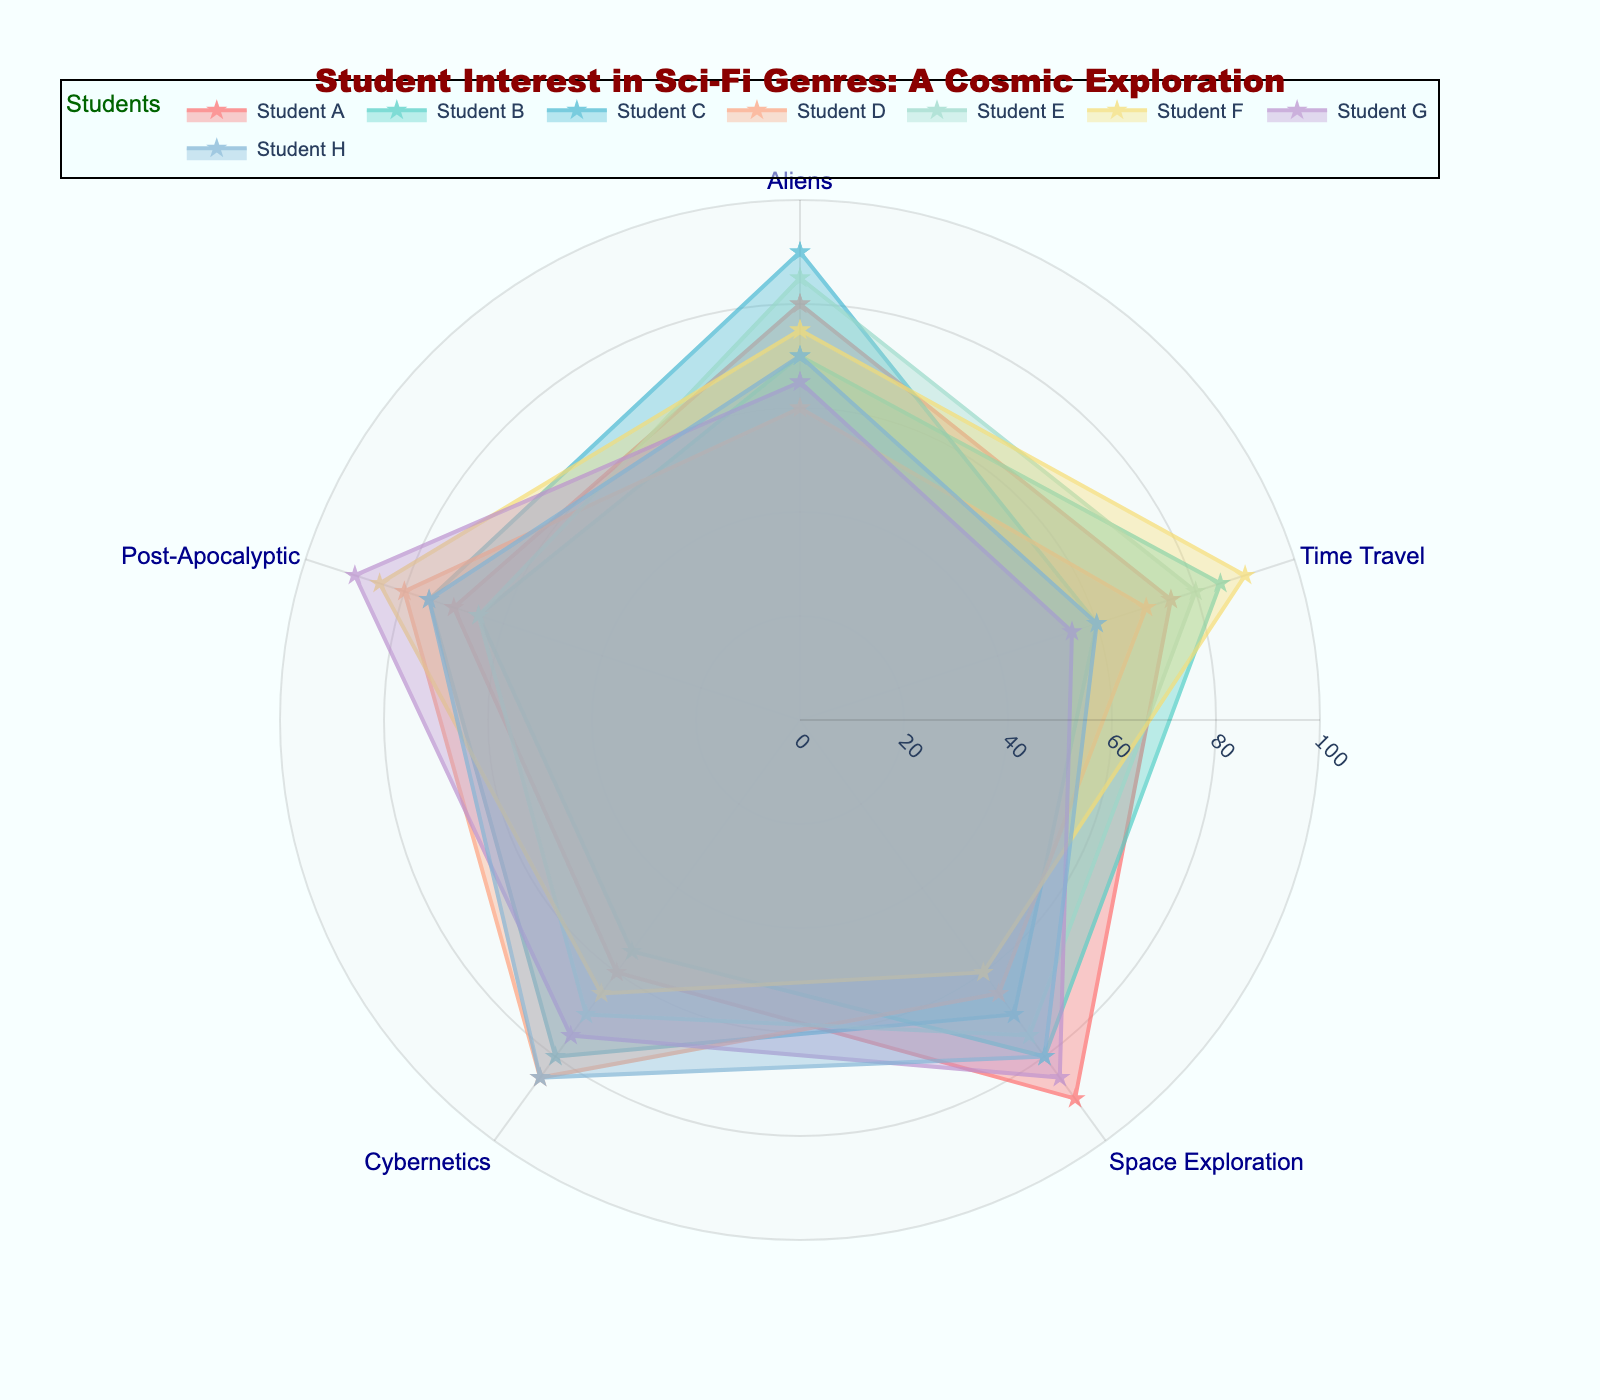what is the highest interest score among all students in the Post-Apocalyptic genre? To find the highest interest score for the Post-Apocalyptic genre, we need to look at each student's interest in this genre. The scores are 70, 65, 75, 80, 65, 85, 90, and 75. The highest score among these is 90.
Answer: 90 which student has the highest combined interest in Time Travel and Space Exploration? To find which student has the highest combined interest in Time Travel and Space Exploration, we need to add the interest scores for these two genres for each student: Student A: 75 + 90 = 165, Student B: 85 + 80 = 165, Student C: 60 + 70 = 130, Student D: 70 + 65 = 135, Student E: 80 + 75 = 155, Student F: 90 + 60 = 150, Student G: 55 + 85 = 140, Student H: 60 + 80 = 140. Students A and B both have a combined interest score of 165.
Answer: Students A and B which student shows the least interest in Cybernetics? We need to look at the Cybernetics score for each student: Student A: 60, Student B: 55, Student C: 80, Student D: 85, Student E: 70, Student F: 65, Student G: 75, Student H: 85. The lowest score is 55, which belongs to Student B.
Answer: Student B how many students have a higher interest in Aliens than in Post-Apocalyptic scenarios? We need to compare the interest scores in Aliens and Post-Apocalyptic scenarios for each student: Student A: 80>70, Student B: 70>65, Student C: 90>75, Student D: 60<80, Student E: 85>65, Student F: 75<85, Student G: 65<90, Student H: 70<75. There are 4 students who have a higher interest in Aliens (A, B, C, E).
Answer: 4 which genre has the highest average interest score among all students? We need to calculate the average interest score for each genre by adding the scores and dividing by the number of students: Aliens: (80+70+90+60+85+75+65+70)/8 = 74.375, Time Travel: (75+85+60+70+80+90+55+60)/8 = 71.875, Space Exploration: (90+80+70+65+75+60+85+80)/8 = 75.625, Cybernetics: (60+55+80+85+70+65+75+85)/8 = 71.875, Post-Apocalyptic: (70+65+75+80+65+85+90+75)/8 = 75. The highest average is for Space Exploration (75.625).
Answer: Space Exploration 